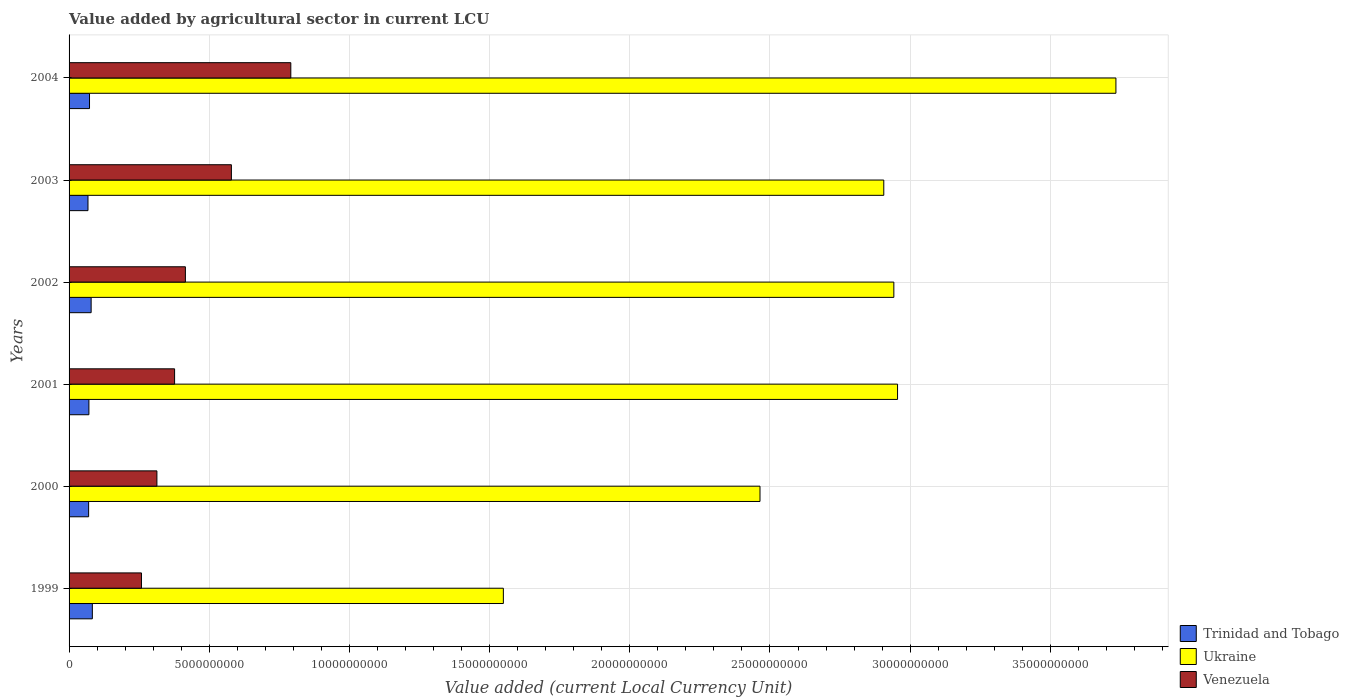Are the number of bars on each tick of the Y-axis equal?
Your answer should be compact. Yes. How many bars are there on the 6th tick from the top?
Make the answer very short. 3. How many bars are there on the 6th tick from the bottom?
Your answer should be compact. 3. What is the label of the 1st group of bars from the top?
Offer a terse response. 2004. In how many cases, is the number of bars for a given year not equal to the number of legend labels?
Your answer should be very brief. 0. What is the value added by agricultural sector in Trinidad and Tobago in 2004?
Offer a terse response. 7.29e+08. Across all years, what is the maximum value added by agricultural sector in Trinidad and Tobago?
Keep it short and to the point. 8.30e+08. Across all years, what is the minimum value added by agricultural sector in Trinidad and Tobago?
Provide a succinct answer. 6.75e+08. In which year was the value added by agricultural sector in Venezuela maximum?
Ensure brevity in your answer.  2004. What is the total value added by agricultural sector in Venezuela in the graph?
Provide a succinct answer. 2.73e+1. What is the difference between the value added by agricultural sector in Trinidad and Tobago in 2000 and that in 2004?
Provide a short and direct response. -3.21e+07. What is the difference between the value added by agricultural sector in Trinidad and Tobago in 2004 and the value added by agricultural sector in Venezuela in 2000?
Your response must be concise. -2.40e+09. What is the average value added by agricultural sector in Trinidad and Tobago per year?
Your response must be concise. 7.38e+08. In the year 1999, what is the difference between the value added by agricultural sector in Ukraine and value added by agricultural sector in Venezuela?
Offer a very short reply. 1.29e+1. What is the ratio of the value added by agricultural sector in Ukraine in 2000 to that in 2004?
Your response must be concise. 0.66. Is the value added by agricultural sector in Venezuela in 2000 less than that in 2004?
Offer a very short reply. Yes. Is the difference between the value added by agricultural sector in Ukraine in 1999 and 2002 greater than the difference between the value added by agricultural sector in Venezuela in 1999 and 2002?
Provide a succinct answer. No. What is the difference between the highest and the second highest value added by agricultural sector in Ukraine?
Your answer should be compact. 7.79e+09. What is the difference between the highest and the lowest value added by agricultural sector in Venezuela?
Make the answer very short. 5.33e+09. In how many years, is the value added by agricultural sector in Ukraine greater than the average value added by agricultural sector in Ukraine taken over all years?
Offer a terse response. 4. What does the 1st bar from the top in 2002 represents?
Ensure brevity in your answer.  Venezuela. What does the 3rd bar from the bottom in 2001 represents?
Provide a short and direct response. Venezuela. What is the difference between two consecutive major ticks on the X-axis?
Provide a succinct answer. 5.00e+09. Are the values on the major ticks of X-axis written in scientific E-notation?
Your answer should be compact. No. How many legend labels are there?
Your answer should be very brief. 3. What is the title of the graph?
Keep it short and to the point. Value added by agricultural sector in current LCU. Does "Denmark" appear as one of the legend labels in the graph?
Provide a short and direct response. No. What is the label or title of the X-axis?
Your answer should be compact. Value added (current Local Currency Unit). What is the label or title of the Y-axis?
Offer a very short reply. Years. What is the Value added (current Local Currency Unit) of Trinidad and Tobago in 1999?
Offer a terse response. 8.30e+08. What is the Value added (current Local Currency Unit) of Ukraine in 1999?
Provide a succinct answer. 1.55e+1. What is the Value added (current Local Currency Unit) in Venezuela in 1999?
Provide a succinct answer. 2.58e+09. What is the Value added (current Local Currency Unit) of Trinidad and Tobago in 2000?
Give a very brief answer. 6.97e+08. What is the Value added (current Local Currency Unit) in Ukraine in 2000?
Offer a terse response. 2.46e+1. What is the Value added (current Local Currency Unit) of Venezuela in 2000?
Ensure brevity in your answer.  3.13e+09. What is the Value added (current Local Currency Unit) of Trinidad and Tobago in 2001?
Give a very brief answer. 7.08e+08. What is the Value added (current Local Currency Unit) of Ukraine in 2001?
Keep it short and to the point. 2.96e+1. What is the Value added (current Local Currency Unit) of Venezuela in 2001?
Provide a short and direct response. 3.76e+09. What is the Value added (current Local Currency Unit) of Trinidad and Tobago in 2002?
Your response must be concise. 7.87e+08. What is the Value added (current Local Currency Unit) in Ukraine in 2002?
Keep it short and to the point. 2.94e+1. What is the Value added (current Local Currency Unit) of Venezuela in 2002?
Make the answer very short. 4.15e+09. What is the Value added (current Local Currency Unit) in Trinidad and Tobago in 2003?
Your answer should be very brief. 6.75e+08. What is the Value added (current Local Currency Unit) of Ukraine in 2003?
Your answer should be compact. 2.91e+1. What is the Value added (current Local Currency Unit) in Venezuela in 2003?
Keep it short and to the point. 5.79e+09. What is the Value added (current Local Currency Unit) in Trinidad and Tobago in 2004?
Make the answer very short. 7.29e+08. What is the Value added (current Local Currency Unit) in Ukraine in 2004?
Your answer should be compact. 3.73e+1. What is the Value added (current Local Currency Unit) of Venezuela in 2004?
Keep it short and to the point. 7.91e+09. Across all years, what is the maximum Value added (current Local Currency Unit) of Trinidad and Tobago?
Offer a very short reply. 8.30e+08. Across all years, what is the maximum Value added (current Local Currency Unit) in Ukraine?
Provide a succinct answer. 3.73e+1. Across all years, what is the maximum Value added (current Local Currency Unit) of Venezuela?
Your answer should be compact. 7.91e+09. Across all years, what is the minimum Value added (current Local Currency Unit) of Trinidad and Tobago?
Make the answer very short. 6.75e+08. Across all years, what is the minimum Value added (current Local Currency Unit) in Ukraine?
Offer a very short reply. 1.55e+1. Across all years, what is the minimum Value added (current Local Currency Unit) in Venezuela?
Your response must be concise. 2.58e+09. What is the total Value added (current Local Currency Unit) in Trinidad and Tobago in the graph?
Your answer should be very brief. 4.43e+09. What is the total Value added (current Local Currency Unit) of Ukraine in the graph?
Give a very brief answer. 1.66e+11. What is the total Value added (current Local Currency Unit) in Venezuela in the graph?
Make the answer very short. 2.73e+1. What is the difference between the Value added (current Local Currency Unit) in Trinidad and Tobago in 1999 and that in 2000?
Your answer should be very brief. 1.33e+08. What is the difference between the Value added (current Local Currency Unit) of Ukraine in 1999 and that in 2000?
Give a very brief answer. -9.15e+09. What is the difference between the Value added (current Local Currency Unit) of Venezuela in 1999 and that in 2000?
Provide a short and direct response. -5.51e+08. What is the difference between the Value added (current Local Currency Unit) of Trinidad and Tobago in 1999 and that in 2001?
Offer a terse response. 1.23e+08. What is the difference between the Value added (current Local Currency Unit) in Ukraine in 1999 and that in 2001?
Give a very brief answer. -1.41e+1. What is the difference between the Value added (current Local Currency Unit) in Venezuela in 1999 and that in 2001?
Keep it short and to the point. -1.18e+09. What is the difference between the Value added (current Local Currency Unit) in Trinidad and Tobago in 1999 and that in 2002?
Ensure brevity in your answer.  4.31e+07. What is the difference between the Value added (current Local Currency Unit) in Ukraine in 1999 and that in 2002?
Your answer should be very brief. -1.39e+1. What is the difference between the Value added (current Local Currency Unit) of Venezuela in 1999 and that in 2002?
Ensure brevity in your answer.  -1.57e+09. What is the difference between the Value added (current Local Currency Unit) in Trinidad and Tobago in 1999 and that in 2003?
Your answer should be very brief. 1.56e+08. What is the difference between the Value added (current Local Currency Unit) in Ukraine in 1999 and that in 2003?
Provide a succinct answer. -1.36e+1. What is the difference between the Value added (current Local Currency Unit) of Venezuela in 1999 and that in 2003?
Keep it short and to the point. -3.21e+09. What is the difference between the Value added (current Local Currency Unit) in Trinidad and Tobago in 1999 and that in 2004?
Your answer should be very brief. 1.01e+08. What is the difference between the Value added (current Local Currency Unit) of Ukraine in 1999 and that in 2004?
Ensure brevity in your answer.  -2.18e+1. What is the difference between the Value added (current Local Currency Unit) in Venezuela in 1999 and that in 2004?
Offer a very short reply. -5.33e+09. What is the difference between the Value added (current Local Currency Unit) in Trinidad and Tobago in 2000 and that in 2001?
Give a very brief answer. -1.03e+07. What is the difference between the Value added (current Local Currency Unit) in Ukraine in 2000 and that in 2001?
Offer a very short reply. -4.91e+09. What is the difference between the Value added (current Local Currency Unit) of Venezuela in 2000 and that in 2001?
Make the answer very short. -6.31e+08. What is the difference between the Value added (current Local Currency Unit) of Trinidad and Tobago in 2000 and that in 2002?
Give a very brief answer. -9.00e+07. What is the difference between the Value added (current Local Currency Unit) in Ukraine in 2000 and that in 2002?
Provide a short and direct response. -4.77e+09. What is the difference between the Value added (current Local Currency Unit) in Venezuela in 2000 and that in 2002?
Ensure brevity in your answer.  -1.02e+09. What is the difference between the Value added (current Local Currency Unit) in Trinidad and Tobago in 2000 and that in 2003?
Make the answer very short. 2.26e+07. What is the difference between the Value added (current Local Currency Unit) of Ukraine in 2000 and that in 2003?
Offer a very short reply. -4.42e+09. What is the difference between the Value added (current Local Currency Unit) in Venezuela in 2000 and that in 2003?
Your answer should be very brief. -2.66e+09. What is the difference between the Value added (current Local Currency Unit) of Trinidad and Tobago in 2000 and that in 2004?
Provide a succinct answer. -3.21e+07. What is the difference between the Value added (current Local Currency Unit) of Ukraine in 2000 and that in 2004?
Offer a terse response. -1.27e+1. What is the difference between the Value added (current Local Currency Unit) in Venezuela in 2000 and that in 2004?
Give a very brief answer. -4.78e+09. What is the difference between the Value added (current Local Currency Unit) in Trinidad and Tobago in 2001 and that in 2002?
Offer a terse response. -7.97e+07. What is the difference between the Value added (current Local Currency Unit) in Ukraine in 2001 and that in 2002?
Your answer should be compact. 1.32e+08. What is the difference between the Value added (current Local Currency Unit) in Venezuela in 2001 and that in 2002?
Provide a succinct answer. -3.85e+08. What is the difference between the Value added (current Local Currency Unit) of Trinidad and Tobago in 2001 and that in 2003?
Offer a very short reply. 3.29e+07. What is the difference between the Value added (current Local Currency Unit) in Ukraine in 2001 and that in 2003?
Ensure brevity in your answer.  4.91e+08. What is the difference between the Value added (current Local Currency Unit) in Venezuela in 2001 and that in 2003?
Give a very brief answer. -2.03e+09. What is the difference between the Value added (current Local Currency Unit) in Trinidad and Tobago in 2001 and that in 2004?
Offer a terse response. -2.18e+07. What is the difference between the Value added (current Local Currency Unit) of Ukraine in 2001 and that in 2004?
Your answer should be very brief. -7.79e+09. What is the difference between the Value added (current Local Currency Unit) in Venezuela in 2001 and that in 2004?
Offer a very short reply. -4.15e+09. What is the difference between the Value added (current Local Currency Unit) in Trinidad and Tobago in 2002 and that in 2003?
Keep it short and to the point. 1.13e+08. What is the difference between the Value added (current Local Currency Unit) in Ukraine in 2002 and that in 2003?
Keep it short and to the point. 3.59e+08. What is the difference between the Value added (current Local Currency Unit) of Venezuela in 2002 and that in 2003?
Your answer should be very brief. -1.64e+09. What is the difference between the Value added (current Local Currency Unit) of Trinidad and Tobago in 2002 and that in 2004?
Give a very brief answer. 5.79e+07. What is the difference between the Value added (current Local Currency Unit) of Ukraine in 2002 and that in 2004?
Provide a short and direct response. -7.92e+09. What is the difference between the Value added (current Local Currency Unit) of Venezuela in 2002 and that in 2004?
Your response must be concise. -3.76e+09. What is the difference between the Value added (current Local Currency Unit) of Trinidad and Tobago in 2003 and that in 2004?
Provide a short and direct response. -5.47e+07. What is the difference between the Value added (current Local Currency Unit) in Ukraine in 2003 and that in 2004?
Offer a very short reply. -8.28e+09. What is the difference between the Value added (current Local Currency Unit) in Venezuela in 2003 and that in 2004?
Make the answer very short. -2.12e+09. What is the difference between the Value added (current Local Currency Unit) in Trinidad and Tobago in 1999 and the Value added (current Local Currency Unit) in Ukraine in 2000?
Offer a very short reply. -2.38e+1. What is the difference between the Value added (current Local Currency Unit) of Trinidad and Tobago in 1999 and the Value added (current Local Currency Unit) of Venezuela in 2000?
Your response must be concise. -2.30e+09. What is the difference between the Value added (current Local Currency Unit) in Ukraine in 1999 and the Value added (current Local Currency Unit) in Venezuela in 2000?
Make the answer very short. 1.24e+1. What is the difference between the Value added (current Local Currency Unit) of Trinidad and Tobago in 1999 and the Value added (current Local Currency Unit) of Ukraine in 2001?
Give a very brief answer. -2.87e+1. What is the difference between the Value added (current Local Currency Unit) of Trinidad and Tobago in 1999 and the Value added (current Local Currency Unit) of Venezuela in 2001?
Offer a very short reply. -2.93e+09. What is the difference between the Value added (current Local Currency Unit) in Ukraine in 1999 and the Value added (current Local Currency Unit) in Venezuela in 2001?
Provide a succinct answer. 1.17e+1. What is the difference between the Value added (current Local Currency Unit) in Trinidad and Tobago in 1999 and the Value added (current Local Currency Unit) in Ukraine in 2002?
Ensure brevity in your answer.  -2.86e+1. What is the difference between the Value added (current Local Currency Unit) in Trinidad and Tobago in 1999 and the Value added (current Local Currency Unit) in Venezuela in 2002?
Your answer should be compact. -3.32e+09. What is the difference between the Value added (current Local Currency Unit) in Ukraine in 1999 and the Value added (current Local Currency Unit) in Venezuela in 2002?
Provide a short and direct response. 1.13e+1. What is the difference between the Value added (current Local Currency Unit) in Trinidad and Tobago in 1999 and the Value added (current Local Currency Unit) in Ukraine in 2003?
Your answer should be very brief. -2.82e+1. What is the difference between the Value added (current Local Currency Unit) of Trinidad and Tobago in 1999 and the Value added (current Local Currency Unit) of Venezuela in 2003?
Offer a very short reply. -4.96e+09. What is the difference between the Value added (current Local Currency Unit) in Ukraine in 1999 and the Value added (current Local Currency Unit) in Venezuela in 2003?
Your response must be concise. 9.70e+09. What is the difference between the Value added (current Local Currency Unit) in Trinidad and Tobago in 1999 and the Value added (current Local Currency Unit) in Ukraine in 2004?
Offer a very short reply. -3.65e+1. What is the difference between the Value added (current Local Currency Unit) in Trinidad and Tobago in 1999 and the Value added (current Local Currency Unit) in Venezuela in 2004?
Give a very brief answer. -7.08e+09. What is the difference between the Value added (current Local Currency Unit) of Ukraine in 1999 and the Value added (current Local Currency Unit) of Venezuela in 2004?
Your answer should be very brief. 7.58e+09. What is the difference between the Value added (current Local Currency Unit) in Trinidad and Tobago in 2000 and the Value added (current Local Currency Unit) in Ukraine in 2001?
Your response must be concise. -2.89e+1. What is the difference between the Value added (current Local Currency Unit) in Trinidad and Tobago in 2000 and the Value added (current Local Currency Unit) in Venezuela in 2001?
Ensure brevity in your answer.  -3.07e+09. What is the difference between the Value added (current Local Currency Unit) of Ukraine in 2000 and the Value added (current Local Currency Unit) of Venezuela in 2001?
Your answer should be very brief. 2.09e+1. What is the difference between the Value added (current Local Currency Unit) of Trinidad and Tobago in 2000 and the Value added (current Local Currency Unit) of Ukraine in 2002?
Ensure brevity in your answer.  -2.87e+1. What is the difference between the Value added (current Local Currency Unit) in Trinidad and Tobago in 2000 and the Value added (current Local Currency Unit) in Venezuela in 2002?
Your response must be concise. -3.45e+09. What is the difference between the Value added (current Local Currency Unit) in Ukraine in 2000 and the Value added (current Local Currency Unit) in Venezuela in 2002?
Provide a short and direct response. 2.05e+1. What is the difference between the Value added (current Local Currency Unit) of Trinidad and Tobago in 2000 and the Value added (current Local Currency Unit) of Ukraine in 2003?
Make the answer very short. -2.84e+1. What is the difference between the Value added (current Local Currency Unit) of Trinidad and Tobago in 2000 and the Value added (current Local Currency Unit) of Venezuela in 2003?
Offer a terse response. -5.09e+09. What is the difference between the Value added (current Local Currency Unit) of Ukraine in 2000 and the Value added (current Local Currency Unit) of Venezuela in 2003?
Your answer should be very brief. 1.89e+1. What is the difference between the Value added (current Local Currency Unit) in Trinidad and Tobago in 2000 and the Value added (current Local Currency Unit) in Ukraine in 2004?
Your answer should be very brief. -3.66e+1. What is the difference between the Value added (current Local Currency Unit) of Trinidad and Tobago in 2000 and the Value added (current Local Currency Unit) of Venezuela in 2004?
Your response must be concise. -7.21e+09. What is the difference between the Value added (current Local Currency Unit) of Ukraine in 2000 and the Value added (current Local Currency Unit) of Venezuela in 2004?
Your response must be concise. 1.67e+1. What is the difference between the Value added (current Local Currency Unit) of Trinidad and Tobago in 2001 and the Value added (current Local Currency Unit) of Ukraine in 2002?
Your response must be concise. -2.87e+1. What is the difference between the Value added (current Local Currency Unit) of Trinidad and Tobago in 2001 and the Value added (current Local Currency Unit) of Venezuela in 2002?
Your answer should be very brief. -3.44e+09. What is the difference between the Value added (current Local Currency Unit) of Ukraine in 2001 and the Value added (current Local Currency Unit) of Venezuela in 2002?
Make the answer very short. 2.54e+1. What is the difference between the Value added (current Local Currency Unit) of Trinidad and Tobago in 2001 and the Value added (current Local Currency Unit) of Ukraine in 2003?
Your answer should be compact. -2.84e+1. What is the difference between the Value added (current Local Currency Unit) in Trinidad and Tobago in 2001 and the Value added (current Local Currency Unit) in Venezuela in 2003?
Make the answer very short. -5.08e+09. What is the difference between the Value added (current Local Currency Unit) of Ukraine in 2001 and the Value added (current Local Currency Unit) of Venezuela in 2003?
Provide a short and direct response. 2.38e+1. What is the difference between the Value added (current Local Currency Unit) in Trinidad and Tobago in 2001 and the Value added (current Local Currency Unit) in Ukraine in 2004?
Offer a very short reply. -3.66e+1. What is the difference between the Value added (current Local Currency Unit) of Trinidad and Tobago in 2001 and the Value added (current Local Currency Unit) of Venezuela in 2004?
Provide a succinct answer. -7.20e+09. What is the difference between the Value added (current Local Currency Unit) in Ukraine in 2001 and the Value added (current Local Currency Unit) in Venezuela in 2004?
Provide a succinct answer. 2.16e+1. What is the difference between the Value added (current Local Currency Unit) of Trinidad and Tobago in 2002 and the Value added (current Local Currency Unit) of Ukraine in 2003?
Keep it short and to the point. -2.83e+1. What is the difference between the Value added (current Local Currency Unit) of Trinidad and Tobago in 2002 and the Value added (current Local Currency Unit) of Venezuela in 2003?
Offer a very short reply. -5.00e+09. What is the difference between the Value added (current Local Currency Unit) in Ukraine in 2002 and the Value added (current Local Currency Unit) in Venezuela in 2003?
Offer a terse response. 2.36e+1. What is the difference between the Value added (current Local Currency Unit) of Trinidad and Tobago in 2002 and the Value added (current Local Currency Unit) of Ukraine in 2004?
Provide a succinct answer. -3.66e+1. What is the difference between the Value added (current Local Currency Unit) of Trinidad and Tobago in 2002 and the Value added (current Local Currency Unit) of Venezuela in 2004?
Offer a very short reply. -7.12e+09. What is the difference between the Value added (current Local Currency Unit) of Ukraine in 2002 and the Value added (current Local Currency Unit) of Venezuela in 2004?
Provide a short and direct response. 2.15e+1. What is the difference between the Value added (current Local Currency Unit) in Trinidad and Tobago in 2003 and the Value added (current Local Currency Unit) in Ukraine in 2004?
Provide a short and direct response. -3.67e+1. What is the difference between the Value added (current Local Currency Unit) of Trinidad and Tobago in 2003 and the Value added (current Local Currency Unit) of Venezuela in 2004?
Your answer should be compact. -7.23e+09. What is the difference between the Value added (current Local Currency Unit) in Ukraine in 2003 and the Value added (current Local Currency Unit) in Venezuela in 2004?
Make the answer very short. 2.11e+1. What is the average Value added (current Local Currency Unit) of Trinidad and Tobago per year?
Make the answer very short. 7.38e+08. What is the average Value added (current Local Currency Unit) in Ukraine per year?
Your answer should be very brief. 2.76e+1. What is the average Value added (current Local Currency Unit) in Venezuela per year?
Offer a very short reply. 4.55e+09. In the year 1999, what is the difference between the Value added (current Local Currency Unit) in Trinidad and Tobago and Value added (current Local Currency Unit) in Ukraine?
Provide a succinct answer. -1.47e+1. In the year 1999, what is the difference between the Value added (current Local Currency Unit) of Trinidad and Tobago and Value added (current Local Currency Unit) of Venezuela?
Your answer should be very brief. -1.75e+09. In the year 1999, what is the difference between the Value added (current Local Currency Unit) of Ukraine and Value added (current Local Currency Unit) of Venezuela?
Provide a succinct answer. 1.29e+1. In the year 2000, what is the difference between the Value added (current Local Currency Unit) in Trinidad and Tobago and Value added (current Local Currency Unit) in Ukraine?
Make the answer very short. -2.39e+1. In the year 2000, what is the difference between the Value added (current Local Currency Unit) in Trinidad and Tobago and Value added (current Local Currency Unit) in Venezuela?
Offer a very short reply. -2.44e+09. In the year 2000, what is the difference between the Value added (current Local Currency Unit) of Ukraine and Value added (current Local Currency Unit) of Venezuela?
Offer a terse response. 2.15e+1. In the year 2001, what is the difference between the Value added (current Local Currency Unit) in Trinidad and Tobago and Value added (current Local Currency Unit) in Ukraine?
Ensure brevity in your answer.  -2.88e+1. In the year 2001, what is the difference between the Value added (current Local Currency Unit) of Trinidad and Tobago and Value added (current Local Currency Unit) of Venezuela?
Ensure brevity in your answer.  -3.06e+09. In the year 2001, what is the difference between the Value added (current Local Currency Unit) of Ukraine and Value added (current Local Currency Unit) of Venezuela?
Your answer should be compact. 2.58e+1. In the year 2002, what is the difference between the Value added (current Local Currency Unit) of Trinidad and Tobago and Value added (current Local Currency Unit) of Ukraine?
Give a very brief answer. -2.86e+1. In the year 2002, what is the difference between the Value added (current Local Currency Unit) in Trinidad and Tobago and Value added (current Local Currency Unit) in Venezuela?
Your response must be concise. -3.36e+09. In the year 2002, what is the difference between the Value added (current Local Currency Unit) of Ukraine and Value added (current Local Currency Unit) of Venezuela?
Offer a terse response. 2.53e+1. In the year 2003, what is the difference between the Value added (current Local Currency Unit) of Trinidad and Tobago and Value added (current Local Currency Unit) of Ukraine?
Provide a succinct answer. -2.84e+1. In the year 2003, what is the difference between the Value added (current Local Currency Unit) in Trinidad and Tobago and Value added (current Local Currency Unit) in Venezuela?
Offer a terse response. -5.11e+09. In the year 2003, what is the difference between the Value added (current Local Currency Unit) of Ukraine and Value added (current Local Currency Unit) of Venezuela?
Your response must be concise. 2.33e+1. In the year 2004, what is the difference between the Value added (current Local Currency Unit) of Trinidad and Tobago and Value added (current Local Currency Unit) of Ukraine?
Offer a terse response. -3.66e+1. In the year 2004, what is the difference between the Value added (current Local Currency Unit) of Trinidad and Tobago and Value added (current Local Currency Unit) of Venezuela?
Your answer should be compact. -7.18e+09. In the year 2004, what is the difference between the Value added (current Local Currency Unit) in Ukraine and Value added (current Local Currency Unit) in Venezuela?
Your answer should be compact. 2.94e+1. What is the ratio of the Value added (current Local Currency Unit) in Trinidad and Tobago in 1999 to that in 2000?
Make the answer very short. 1.19. What is the ratio of the Value added (current Local Currency Unit) in Ukraine in 1999 to that in 2000?
Keep it short and to the point. 0.63. What is the ratio of the Value added (current Local Currency Unit) of Venezuela in 1999 to that in 2000?
Offer a very short reply. 0.82. What is the ratio of the Value added (current Local Currency Unit) of Trinidad and Tobago in 1999 to that in 2001?
Your answer should be very brief. 1.17. What is the ratio of the Value added (current Local Currency Unit) in Ukraine in 1999 to that in 2001?
Your response must be concise. 0.52. What is the ratio of the Value added (current Local Currency Unit) of Venezuela in 1999 to that in 2001?
Offer a terse response. 0.69. What is the ratio of the Value added (current Local Currency Unit) in Trinidad and Tobago in 1999 to that in 2002?
Provide a succinct answer. 1.05. What is the ratio of the Value added (current Local Currency Unit) in Ukraine in 1999 to that in 2002?
Offer a terse response. 0.53. What is the ratio of the Value added (current Local Currency Unit) of Venezuela in 1999 to that in 2002?
Offer a very short reply. 0.62. What is the ratio of the Value added (current Local Currency Unit) of Trinidad and Tobago in 1999 to that in 2003?
Offer a terse response. 1.23. What is the ratio of the Value added (current Local Currency Unit) in Ukraine in 1999 to that in 2003?
Your answer should be very brief. 0.53. What is the ratio of the Value added (current Local Currency Unit) in Venezuela in 1999 to that in 2003?
Your answer should be very brief. 0.45. What is the ratio of the Value added (current Local Currency Unit) of Trinidad and Tobago in 1999 to that in 2004?
Provide a short and direct response. 1.14. What is the ratio of the Value added (current Local Currency Unit) of Ukraine in 1999 to that in 2004?
Ensure brevity in your answer.  0.41. What is the ratio of the Value added (current Local Currency Unit) of Venezuela in 1999 to that in 2004?
Make the answer very short. 0.33. What is the ratio of the Value added (current Local Currency Unit) of Trinidad and Tobago in 2000 to that in 2001?
Your response must be concise. 0.99. What is the ratio of the Value added (current Local Currency Unit) in Ukraine in 2000 to that in 2001?
Offer a very short reply. 0.83. What is the ratio of the Value added (current Local Currency Unit) in Venezuela in 2000 to that in 2001?
Provide a short and direct response. 0.83. What is the ratio of the Value added (current Local Currency Unit) in Trinidad and Tobago in 2000 to that in 2002?
Your response must be concise. 0.89. What is the ratio of the Value added (current Local Currency Unit) of Ukraine in 2000 to that in 2002?
Your answer should be compact. 0.84. What is the ratio of the Value added (current Local Currency Unit) of Venezuela in 2000 to that in 2002?
Make the answer very short. 0.76. What is the ratio of the Value added (current Local Currency Unit) of Trinidad and Tobago in 2000 to that in 2003?
Keep it short and to the point. 1.03. What is the ratio of the Value added (current Local Currency Unit) in Ukraine in 2000 to that in 2003?
Ensure brevity in your answer.  0.85. What is the ratio of the Value added (current Local Currency Unit) in Venezuela in 2000 to that in 2003?
Your response must be concise. 0.54. What is the ratio of the Value added (current Local Currency Unit) of Trinidad and Tobago in 2000 to that in 2004?
Offer a very short reply. 0.96. What is the ratio of the Value added (current Local Currency Unit) in Ukraine in 2000 to that in 2004?
Your answer should be compact. 0.66. What is the ratio of the Value added (current Local Currency Unit) of Venezuela in 2000 to that in 2004?
Offer a terse response. 0.4. What is the ratio of the Value added (current Local Currency Unit) of Trinidad and Tobago in 2001 to that in 2002?
Offer a terse response. 0.9. What is the ratio of the Value added (current Local Currency Unit) in Venezuela in 2001 to that in 2002?
Offer a very short reply. 0.91. What is the ratio of the Value added (current Local Currency Unit) of Trinidad and Tobago in 2001 to that in 2003?
Keep it short and to the point. 1.05. What is the ratio of the Value added (current Local Currency Unit) in Ukraine in 2001 to that in 2003?
Your response must be concise. 1.02. What is the ratio of the Value added (current Local Currency Unit) in Venezuela in 2001 to that in 2003?
Keep it short and to the point. 0.65. What is the ratio of the Value added (current Local Currency Unit) in Trinidad and Tobago in 2001 to that in 2004?
Make the answer very short. 0.97. What is the ratio of the Value added (current Local Currency Unit) in Ukraine in 2001 to that in 2004?
Offer a terse response. 0.79. What is the ratio of the Value added (current Local Currency Unit) in Venezuela in 2001 to that in 2004?
Keep it short and to the point. 0.48. What is the ratio of the Value added (current Local Currency Unit) in Trinidad and Tobago in 2002 to that in 2003?
Give a very brief answer. 1.17. What is the ratio of the Value added (current Local Currency Unit) in Ukraine in 2002 to that in 2003?
Give a very brief answer. 1.01. What is the ratio of the Value added (current Local Currency Unit) in Venezuela in 2002 to that in 2003?
Keep it short and to the point. 0.72. What is the ratio of the Value added (current Local Currency Unit) in Trinidad and Tobago in 2002 to that in 2004?
Your answer should be compact. 1.08. What is the ratio of the Value added (current Local Currency Unit) in Ukraine in 2002 to that in 2004?
Give a very brief answer. 0.79. What is the ratio of the Value added (current Local Currency Unit) in Venezuela in 2002 to that in 2004?
Offer a very short reply. 0.52. What is the ratio of the Value added (current Local Currency Unit) in Trinidad and Tobago in 2003 to that in 2004?
Keep it short and to the point. 0.93. What is the ratio of the Value added (current Local Currency Unit) in Ukraine in 2003 to that in 2004?
Ensure brevity in your answer.  0.78. What is the ratio of the Value added (current Local Currency Unit) in Venezuela in 2003 to that in 2004?
Ensure brevity in your answer.  0.73. What is the difference between the highest and the second highest Value added (current Local Currency Unit) in Trinidad and Tobago?
Offer a very short reply. 4.31e+07. What is the difference between the highest and the second highest Value added (current Local Currency Unit) of Ukraine?
Give a very brief answer. 7.79e+09. What is the difference between the highest and the second highest Value added (current Local Currency Unit) in Venezuela?
Ensure brevity in your answer.  2.12e+09. What is the difference between the highest and the lowest Value added (current Local Currency Unit) of Trinidad and Tobago?
Provide a succinct answer. 1.56e+08. What is the difference between the highest and the lowest Value added (current Local Currency Unit) of Ukraine?
Offer a very short reply. 2.18e+1. What is the difference between the highest and the lowest Value added (current Local Currency Unit) of Venezuela?
Offer a very short reply. 5.33e+09. 